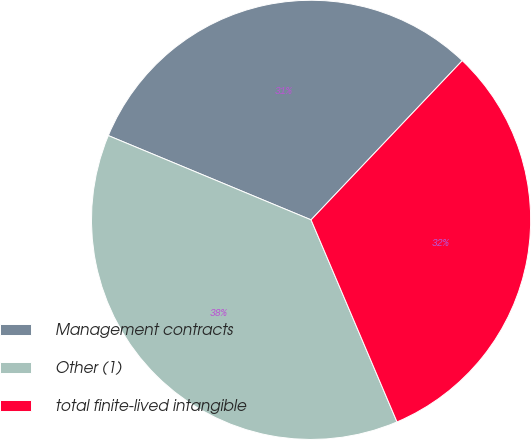<chart> <loc_0><loc_0><loc_500><loc_500><pie_chart><fcel>Management contracts<fcel>Other (1)<fcel>total finite-lived intangible<nl><fcel>30.82%<fcel>37.67%<fcel>31.51%<nl></chart> 